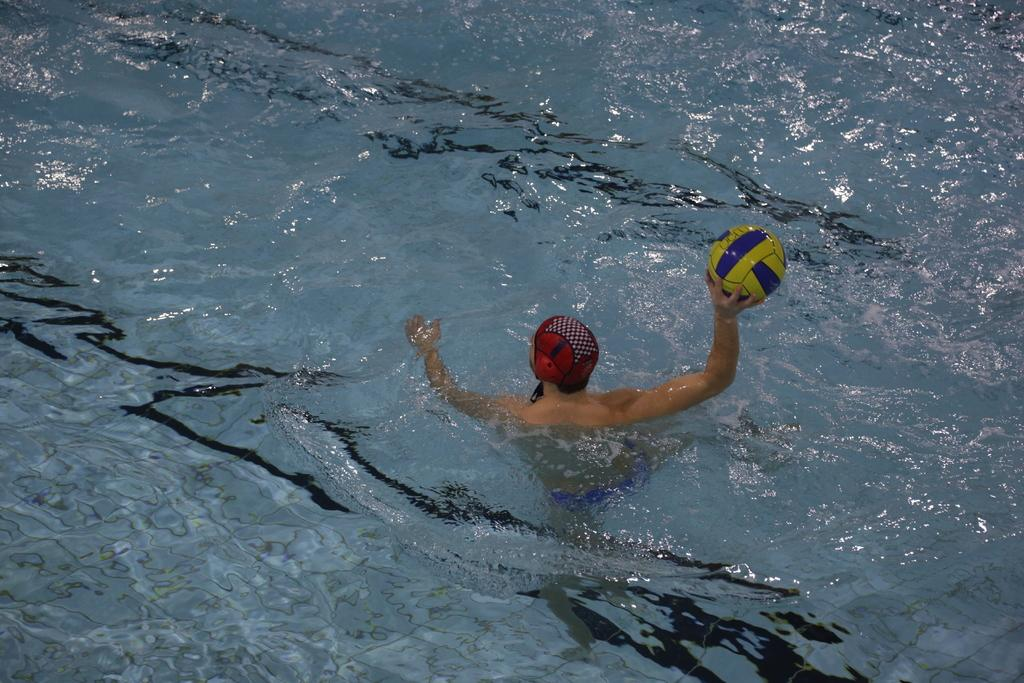Who is present in the image? There is a person in the image. What is the person holding in the image? The person is holding a ball. Where is the ball located in the image? The ball is visible on water. What is the rate of the shoe's movement in the image? There is no shoe present in the image, so it is not possible to determine its rate of movement. 